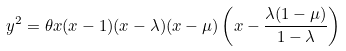Convert formula to latex. <formula><loc_0><loc_0><loc_500><loc_500>y ^ { 2 } = \theta x ( x - 1 ) ( x - \lambda ) ( x - \mu ) \left ( x - \frac { \lambda ( 1 - \mu ) } { 1 - \lambda } \right )</formula> 